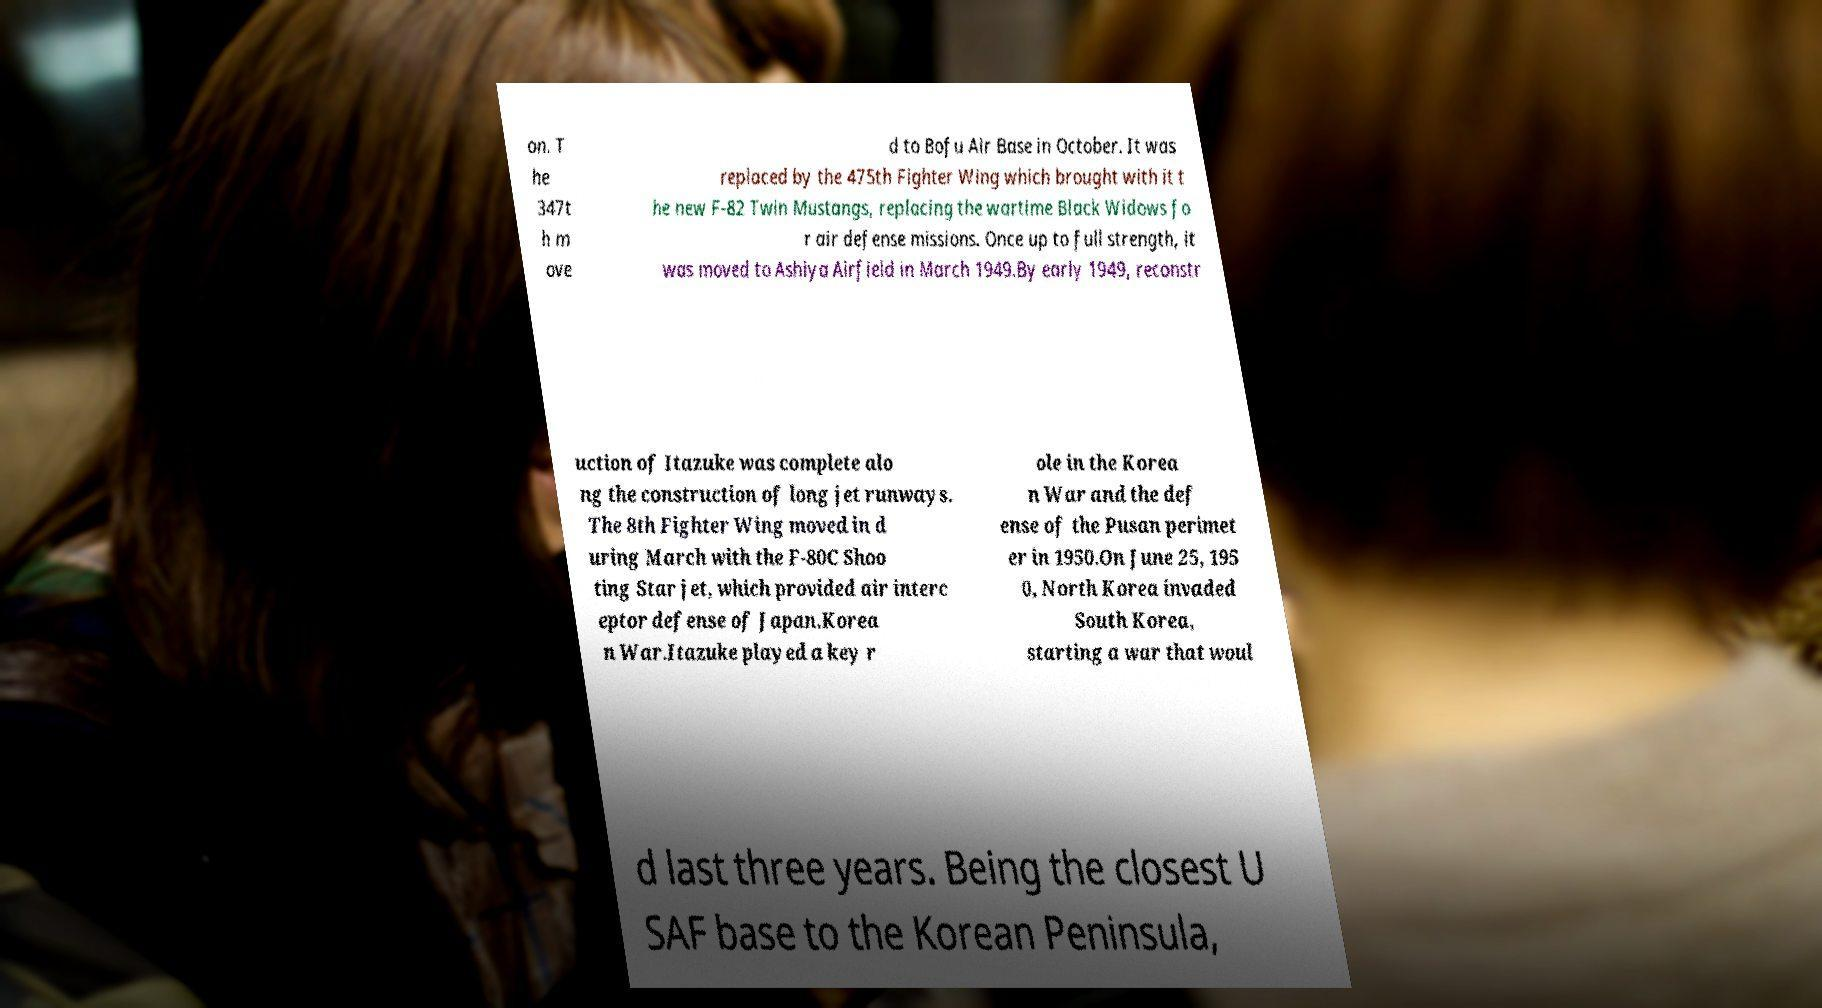Could you extract and type out the text from this image? on. T he 347t h m ove d to Bofu Air Base in October. It was replaced by the 475th Fighter Wing which brought with it t he new F-82 Twin Mustangs, replacing the wartime Black Widows fo r air defense missions. Once up to full strength, it was moved to Ashiya Airfield in March 1949.By early 1949, reconstr uction of Itazuke was complete alo ng the construction of long jet runways. The 8th Fighter Wing moved in d uring March with the F-80C Shoo ting Star jet, which provided air interc eptor defense of Japan.Korea n War.Itazuke played a key r ole in the Korea n War and the def ense of the Pusan perimet er in 1950.On June 25, 195 0, North Korea invaded South Korea, starting a war that woul d last three years. Being the closest U SAF base to the Korean Peninsula, 